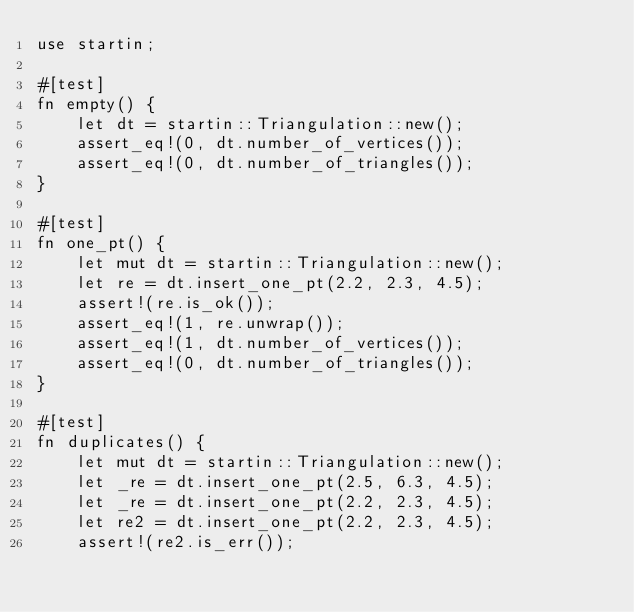Convert code to text. <code><loc_0><loc_0><loc_500><loc_500><_Rust_>use startin;

#[test]
fn empty() {
    let dt = startin::Triangulation::new();
    assert_eq!(0, dt.number_of_vertices());
    assert_eq!(0, dt.number_of_triangles());
}

#[test]
fn one_pt() {
    let mut dt = startin::Triangulation::new();
    let re = dt.insert_one_pt(2.2, 2.3, 4.5);
    assert!(re.is_ok());
    assert_eq!(1, re.unwrap());
    assert_eq!(1, dt.number_of_vertices());
    assert_eq!(0, dt.number_of_triangles());
}

#[test]
fn duplicates() {
    let mut dt = startin::Triangulation::new();
    let _re = dt.insert_one_pt(2.5, 6.3, 4.5);
    let _re = dt.insert_one_pt(2.2, 2.3, 4.5);
    let re2 = dt.insert_one_pt(2.2, 2.3, 4.5);
    assert!(re2.is_err());</code> 